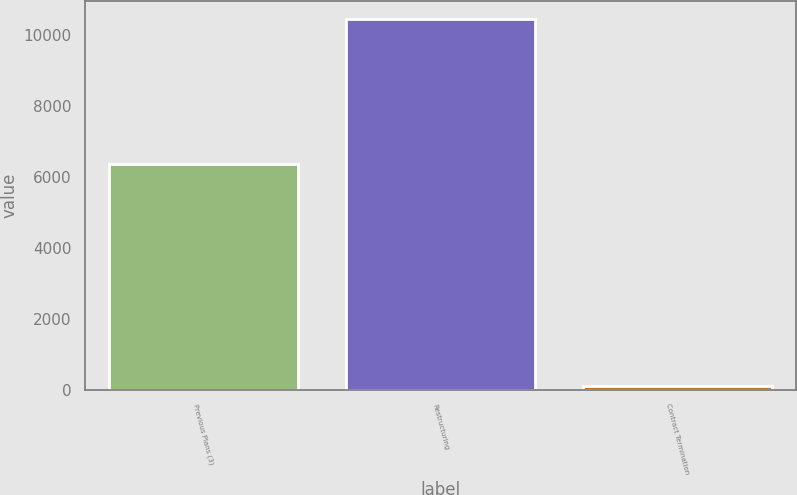Convert chart to OTSL. <chart><loc_0><loc_0><loc_500><loc_500><bar_chart><fcel>Previous Plans (3)<fcel>Restructuring<fcel>Contract Termination<nl><fcel>6352<fcel>10424<fcel>117<nl></chart> 